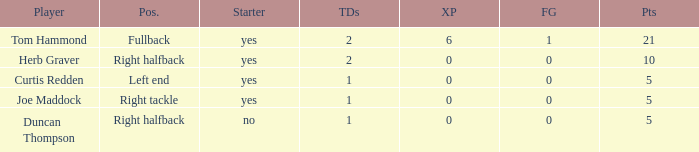Name the most extra points for right tackle 0.0. 